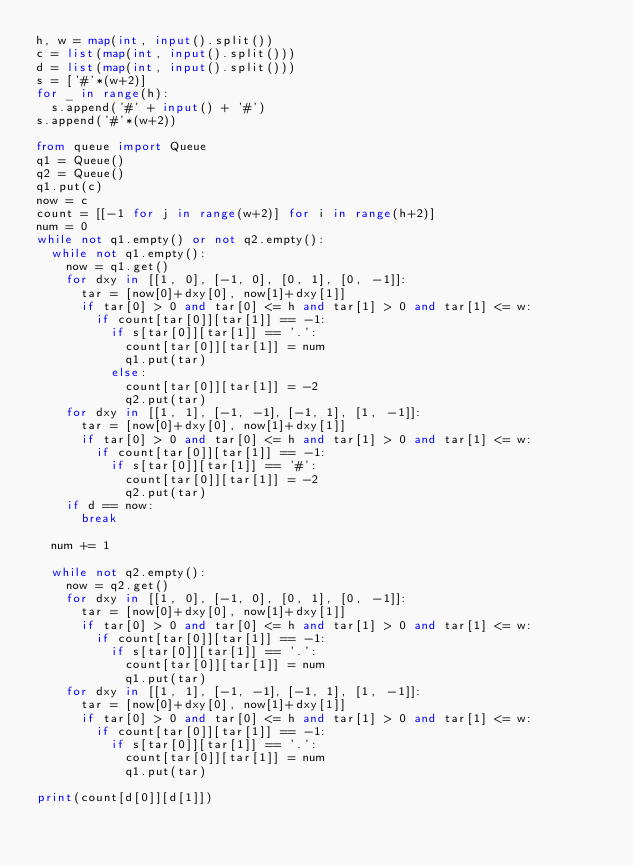<code> <loc_0><loc_0><loc_500><loc_500><_Python_>h, w = map(int, input().split())
c = list(map(int, input().split()))
d = list(map(int, input().split()))
s = ['#'*(w+2)]
for _ in range(h):
  s.append('#' + input() + '#')
s.append('#'*(w+2))

from queue import Queue
q1 = Queue()
q2 = Queue()
q1.put(c)
now = c
count = [[-1 for j in range(w+2)] for i in range(h+2)]
num = 0
while not q1.empty() or not q2.empty():
  while not q1.empty():
    now = q1.get()
    for dxy in [[1, 0], [-1, 0], [0, 1], [0, -1]]:
      tar = [now[0]+dxy[0], now[1]+dxy[1]]
      if tar[0] > 0 and tar[0] <= h and tar[1] > 0 and tar[1] <= w:
        if count[tar[0]][tar[1]] == -1:
          if s[tar[0]][tar[1]] == '.':
            count[tar[0]][tar[1]] = num
            q1.put(tar)
          else:
            count[tar[0]][tar[1]] = -2
            q2.put(tar)
    for dxy in [[1, 1], [-1, -1], [-1, 1], [1, -1]]:
      tar = [now[0]+dxy[0], now[1]+dxy[1]]
      if tar[0] > 0 and tar[0] <= h and tar[1] > 0 and tar[1] <= w:
        if count[tar[0]][tar[1]] == -1:
          if s[tar[0]][tar[1]] == '#':
            count[tar[0]][tar[1]] = -2
            q2.put(tar)
    if d == now:
      break
            
  num += 1
            
  while not q2.empty():
    now = q2.get()
    for dxy in [[1, 0], [-1, 0], [0, 1], [0, -1]]:
      tar = [now[0]+dxy[0], now[1]+dxy[1]]
      if tar[0] > 0 and tar[0] <= h and tar[1] > 0 and tar[1] <= w:
        if count[tar[0]][tar[1]] == -1:
          if s[tar[0]][tar[1]] == '.':
            count[tar[0]][tar[1]] = num
            q1.put(tar)
    for dxy in [[1, 1], [-1, -1], [-1, 1], [1, -1]]:
      tar = [now[0]+dxy[0], now[1]+dxy[1]]
      if tar[0] > 0 and tar[0] <= h and tar[1] > 0 and tar[1] <= w:
        if count[tar[0]][tar[1]] == -1:
          if s[tar[0]][tar[1]] == '.':
            count[tar[0]][tar[1]] = num
            q1.put(tar)
            
print(count[d[0]][d[1]])</code> 